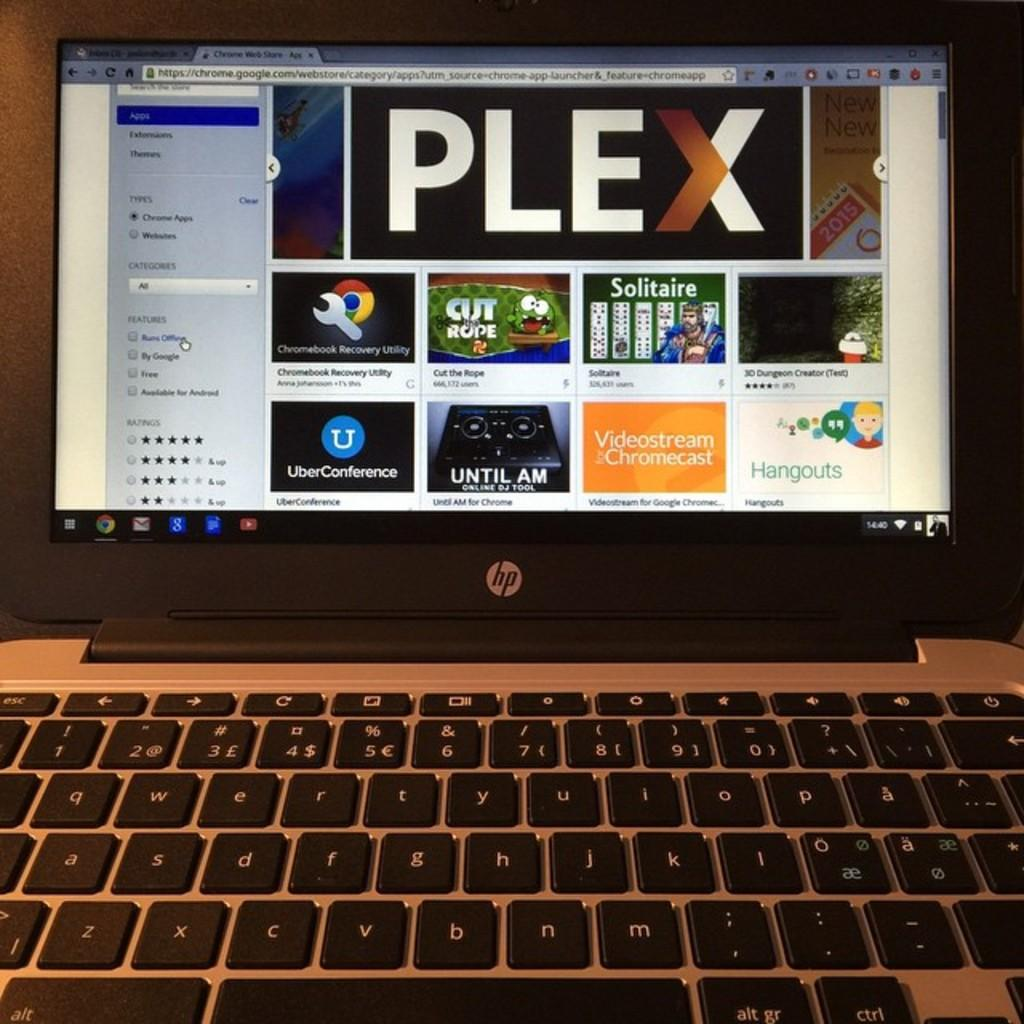What electronic device is present in the image? There is a laptop in the image. What can be seen on the laptop's screen? Different applications are visible on the laptop's screen. What type of hospital is depicted in the image? There is no hospital present in the image; it features a laptop with different applications on its screen. What design elements can be seen in the image? The image does not show any design elements; it features a laptop with different applications on its screen. 